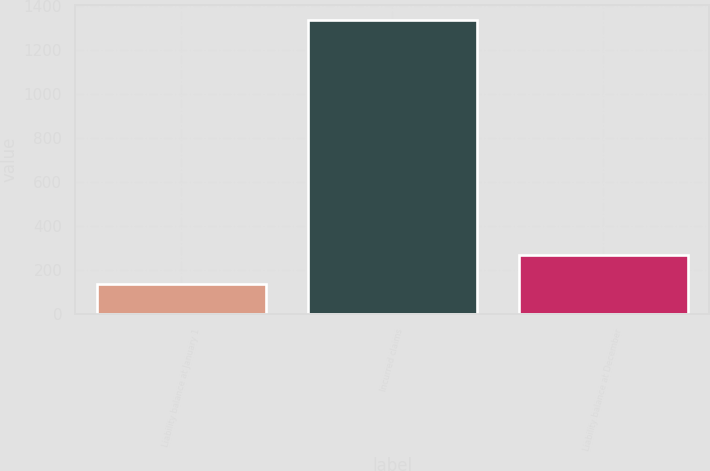Convert chart. <chart><loc_0><loc_0><loc_500><loc_500><bar_chart><fcel>Liability balance at January 1<fcel>Incurred claims<fcel>Liability balance at December<nl><fcel>136<fcel>1335<fcel>269.5<nl></chart> 